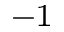<formula> <loc_0><loc_0><loc_500><loc_500>^ { - 1 }</formula> 